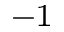<formula> <loc_0><loc_0><loc_500><loc_500>^ { - 1 }</formula> 